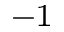<formula> <loc_0><loc_0><loc_500><loc_500>^ { - 1 }</formula> 